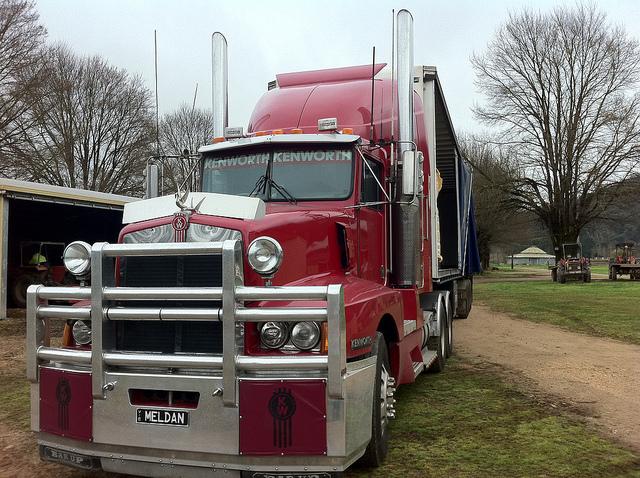Are there any people next to the truck?
Keep it brief. No. Where is the truck?
Keep it brief. Grass. Which Steven King movie does this picture remind you of?
Short answer required. Maximum overdrive. What color is the truck?
Write a very short answer. Red. Is this a red fire truck?
Quick response, please. No. What is the driver of this vehicle's likely profession?
Give a very brief answer. Truck driver. 